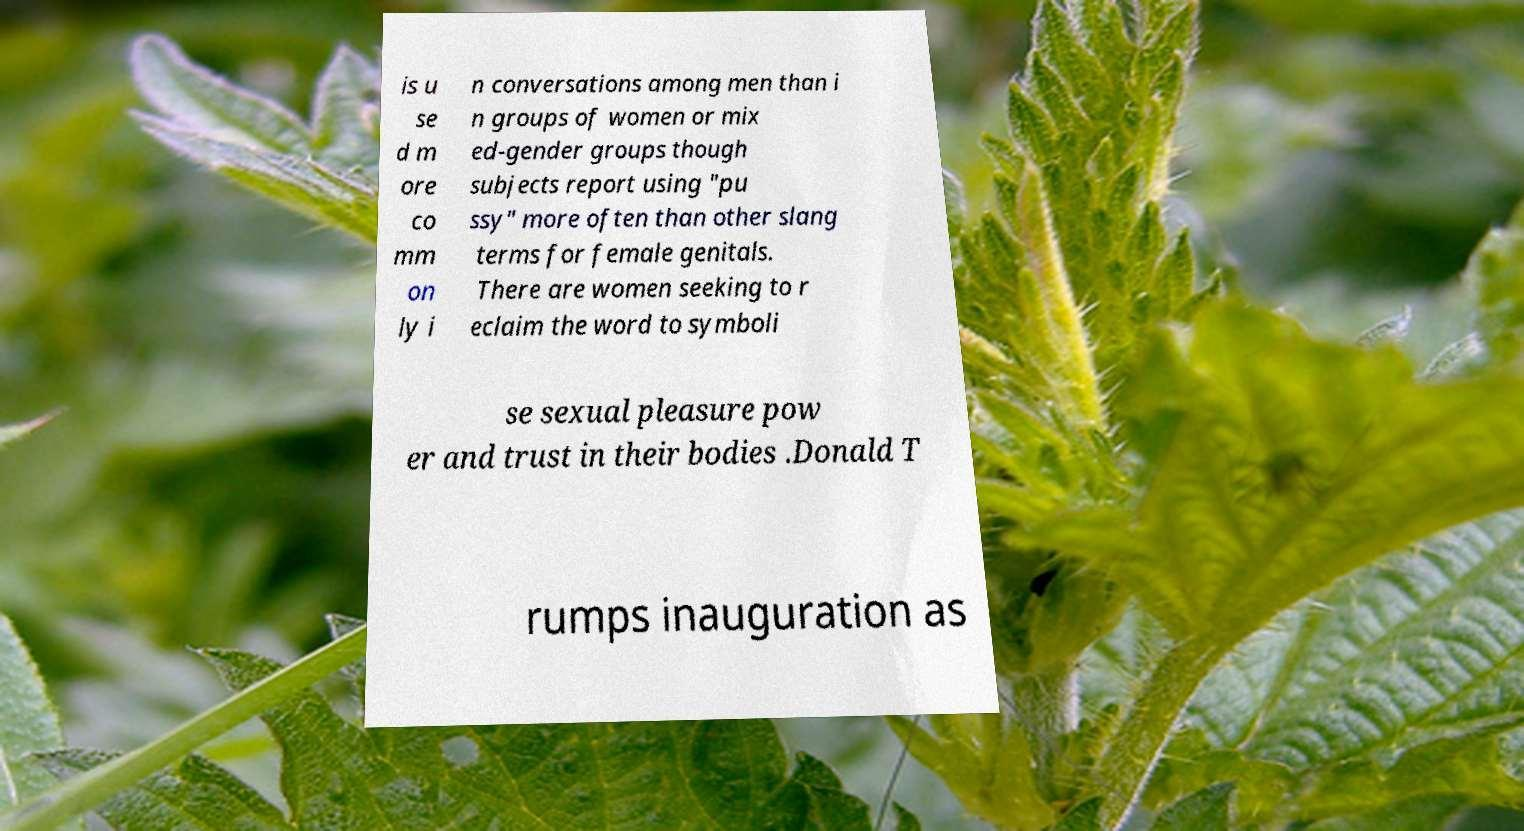Please read and relay the text visible in this image. What does it say? is u se d m ore co mm on ly i n conversations among men than i n groups of women or mix ed-gender groups though subjects report using "pu ssy" more often than other slang terms for female genitals. There are women seeking to r eclaim the word to symboli se sexual pleasure pow er and trust in their bodies .Donald T rumps inauguration as 